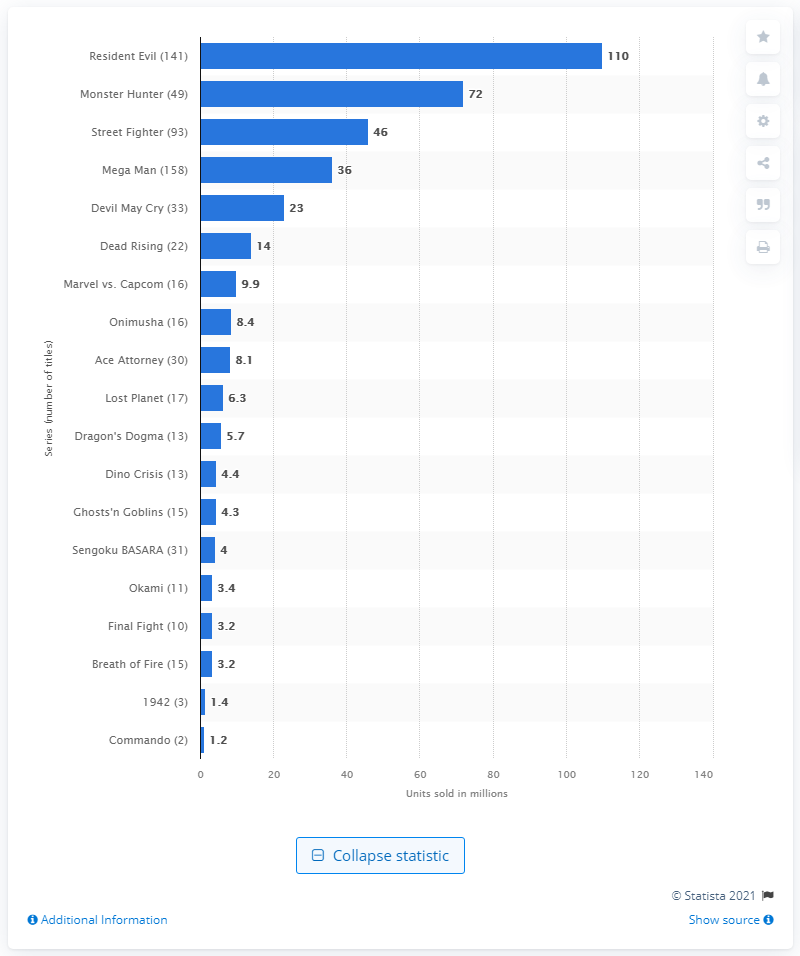Indicate a few pertinent items in this graphic. The Monster Hunter franchise had a total of 72 game unit sales. 